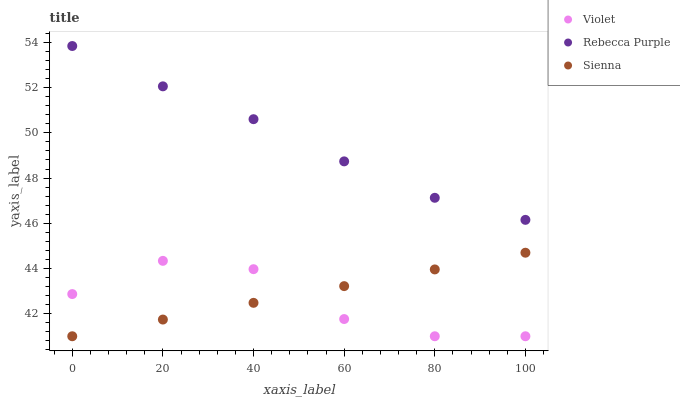Does Violet have the minimum area under the curve?
Answer yes or no. Yes. Does Rebecca Purple have the maximum area under the curve?
Answer yes or no. Yes. Does Rebecca Purple have the minimum area under the curve?
Answer yes or no. No. Does Violet have the maximum area under the curve?
Answer yes or no. No. Is Sienna the smoothest?
Answer yes or no. Yes. Is Violet the roughest?
Answer yes or no. Yes. Is Rebecca Purple the smoothest?
Answer yes or no. No. Is Rebecca Purple the roughest?
Answer yes or no. No. Does Sienna have the lowest value?
Answer yes or no. Yes. Does Rebecca Purple have the lowest value?
Answer yes or no. No. Does Rebecca Purple have the highest value?
Answer yes or no. Yes. Does Violet have the highest value?
Answer yes or no. No. Is Violet less than Rebecca Purple?
Answer yes or no. Yes. Is Rebecca Purple greater than Sienna?
Answer yes or no. Yes. Does Violet intersect Sienna?
Answer yes or no. Yes. Is Violet less than Sienna?
Answer yes or no. No. Is Violet greater than Sienna?
Answer yes or no. No. Does Violet intersect Rebecca Purple?
Answer yes or no. No. 